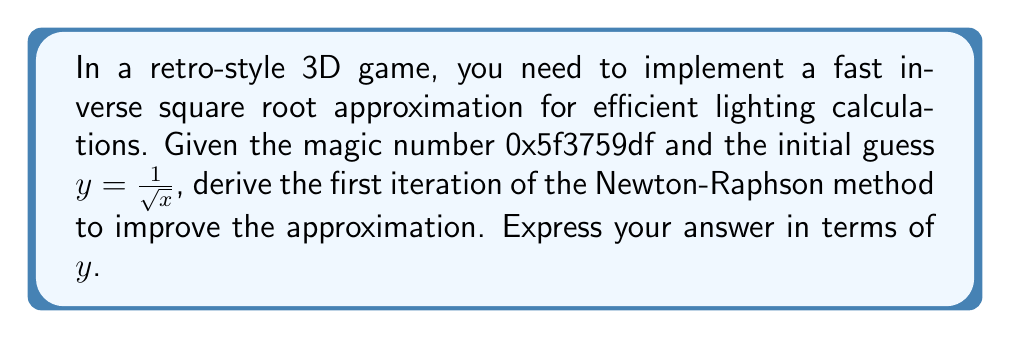Show me your answer to this math problem. 1) The fast inverse square root algorithm uses the Newton-Raphson method to improve an initial guess. The iteration formula is:

   $$y_{n+1} = y_n(1.5 - 0.5xy_n^2)$$

2) To derive this, we start with the function $f(y) = \frac{1}{y^2} - x$, where we want $f(y) = 0$.

3) The derivative of this function is $f'(y) = -\frac{2}{y^3}$.

4) The Newton-Raphson method is given by:

   $$y_{n+1} = y_n - \frac{f(y_n)}{f'(y_n)}$$

5) Substituting our function and its derivative:

   $$y_{n+1} = y_n - \frac{\frac{1}{y_n^2} - x}{-\frac{2}{y_n^3}}$$

6) Simplifying:

   $$y_{n+1} = y_n + \frac{y_n^3}{2}(\frac{1}{y_n^2} - x)$$

   $$y_{n+1} = y_n + \frac{y_n}{2}(1 - xy_n^2)$$

   $$y_{n+1} = y_n(\frac{3}{2} - \frac{1}{2}xy_n^2)$$

   $$y_{n+1} = y_n(1.5 - 0.5xy_n^2)$$

This is the first iteration of the Newton-Raphson method for the fast inverse square root approximation.
Answer: $y(1.5 - 0.5xy^2)$ 